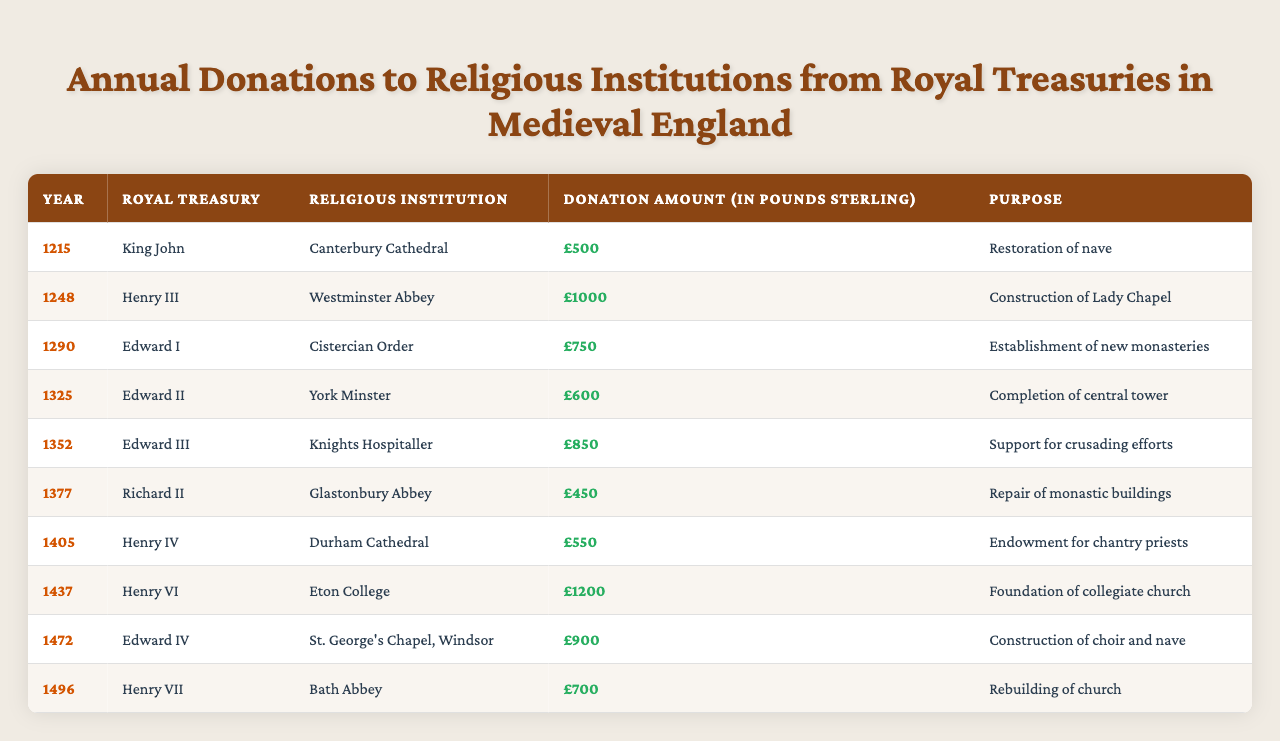What was the highest donation amount recorded in the table? The table shows various donation amounts for each year. The maximum value is £1200 from Henry VI to Eton College in 1437.
Answer: £1200 Who received donations from Edward I? The table lists that Edward I made a donation to the Cistercian Order in 1290.
Answer: Cistercian Order What was the donation amount for the construction of the Lady Chapel in Westminster Abbey? The table specifies that Henry III donated £1000 for this purpose in 1248.
Answer: £1000 How many donations were made for the purpose of construction or rebuilding? The relevant donations for construction or rebuilding are from Westminster Abbey (£1000), Glastonbury Abbey (£450), St. George's Chapel (£900), and Bath Abbey (£700). Thus, there are four instances.
Answer: 4 Did Richard II make a donation greater than £500? In the table, Richard II's donation amount to Glastonbury Abbey was £450, which is not greater than £500.
Answer: No What is the average donation amount across all entries in the table? The donation amounts are £500, £1000, £750, £600, £850, £450, £550, £1200, £900, and £700. Adding them gives £5250, and dividing this total by the 10 donations results in an average of £525.
Answer: £525 Which religious institution received the least financial support? According to the table, Glastonbury Abbey received the least amount of £450 from Richard II in 1377.
Answer: Glastonbury Abbey Find the total amount donated for the support of religious institutions in the 14th century (1300-1399). The donations within this range are: Edward II (£600), Edward III (£850), and Richard II (£450). Summing these amounts gives £600 + £850 + £450 = £1900.
Answer: £1900 Did any donations occur in the 15th century, and if so, which year had the highest amount? The table features donations in the 15th century from Henry IV in 1405 (£550), Henry VI in 1437 (£1200), and Edward IV in 1472 (£900). The highest amount is £1200 in 1437.
Answer: Yes, £1200 in 1437 What was the total number of different royal treasuries listed in the table? The royal treasuries mentioned are King John, Henry III, Edward I, Edward II, Edward III, Richard II, Henry IV, Henry VI, Edward IV, and Henry VII, making a total of 10 different royal treasuries.
Answer: 10 